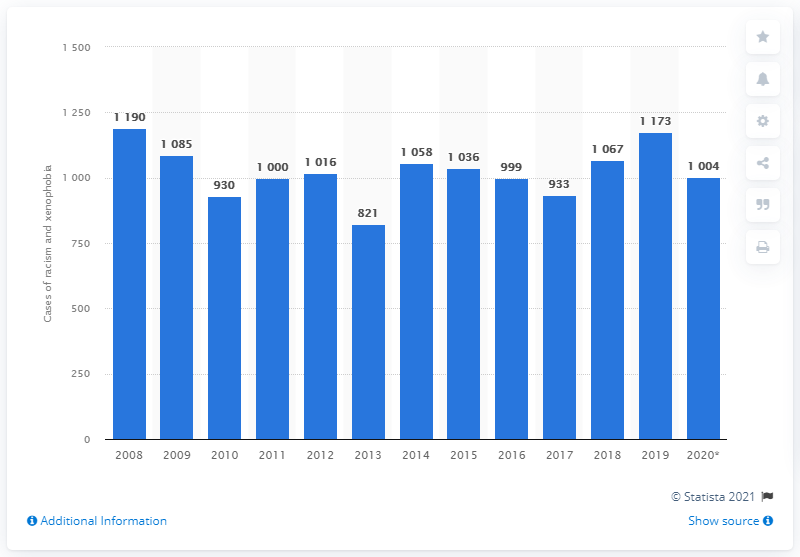Mention a couple of crucial points in this snapshot. The number of cases of racism and xenophobia peaked in 2008. 